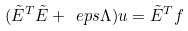<formula> <loc_0><loc_0><loc_500><loc_500>( \tilde { E } ^ { T } \tilde { E } + \ e p s \Lambda ) u = \tilde { E } ^ { T } f</formula> 